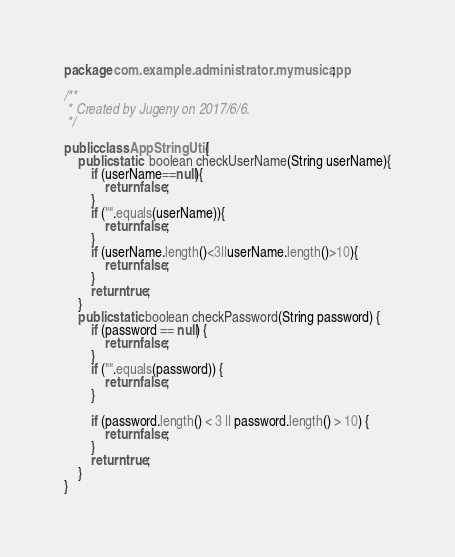Convert code to text. <code><loc_0><loc_0><loc_500><loc_500><_Java_>package com.example.administrator.mymusicapp;

/**
 * Created by Jugeny on 2017/6/6.
 */

public class AppStringUtil {
    public static  boolean checkUserName(String userName){
        if (userName==null){
            return false;
        }
        if ("".equals(userName)){
            return false;
        }
        if (userName.length()<3||userName.length()>10){
            return false;
        }
        return true;
    }
    public static boolean checkPassword(String password) {
        if (password == null) {
            return false;
        }
        if ("".equals(password)) {
            return false;
        }

        if (password.length() < 3 || password.length() > 10) {
            return false;
        }
        return true;
    }
}
</code> 